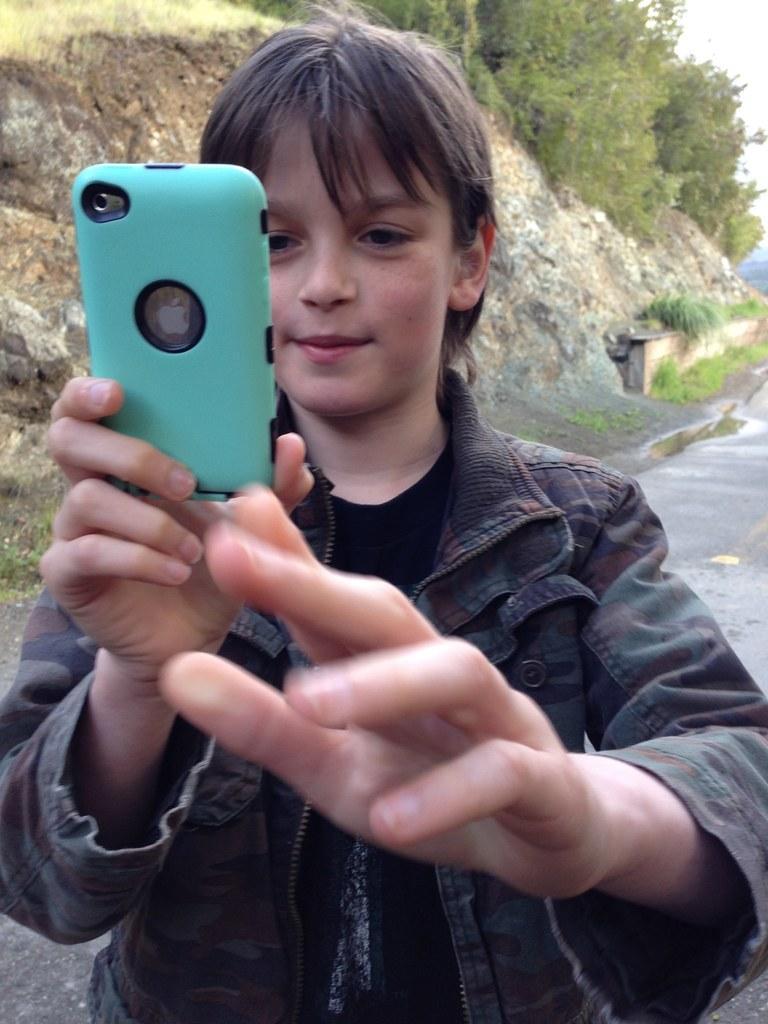Could you give a brief overview of what you see in this image? In this picture we can see a boy holding a phone with his hand. On the background there are some trees and this is the sky. 